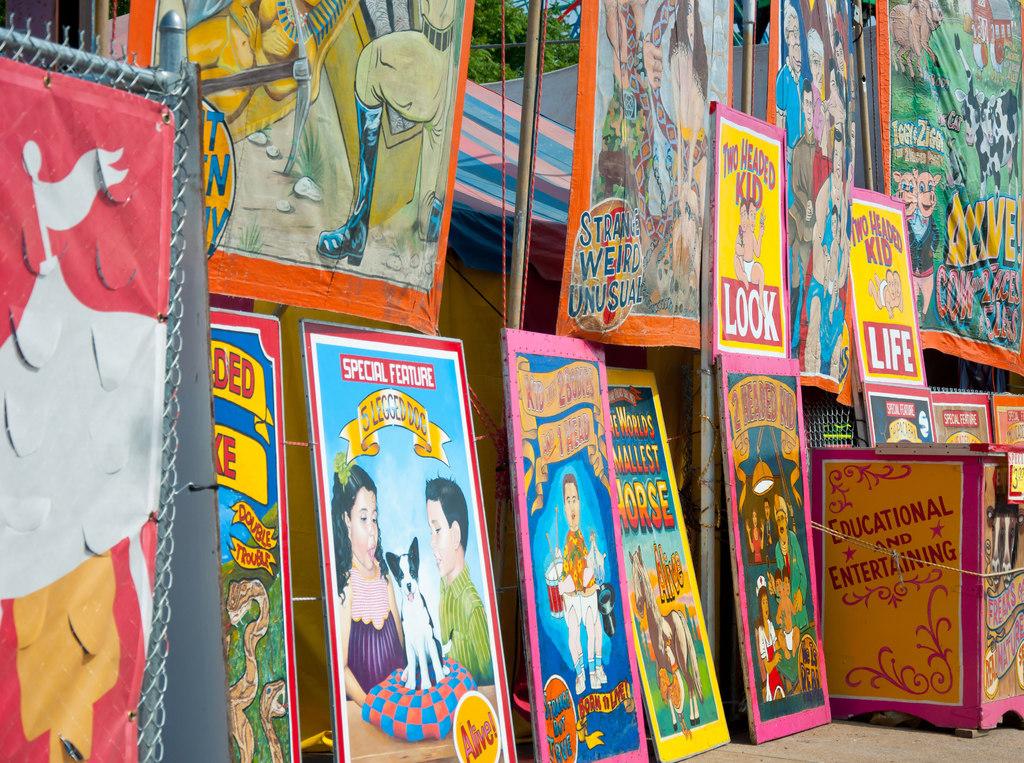Did that sign on the right say two headed kid?
Keep it short and to the point. Yes. 